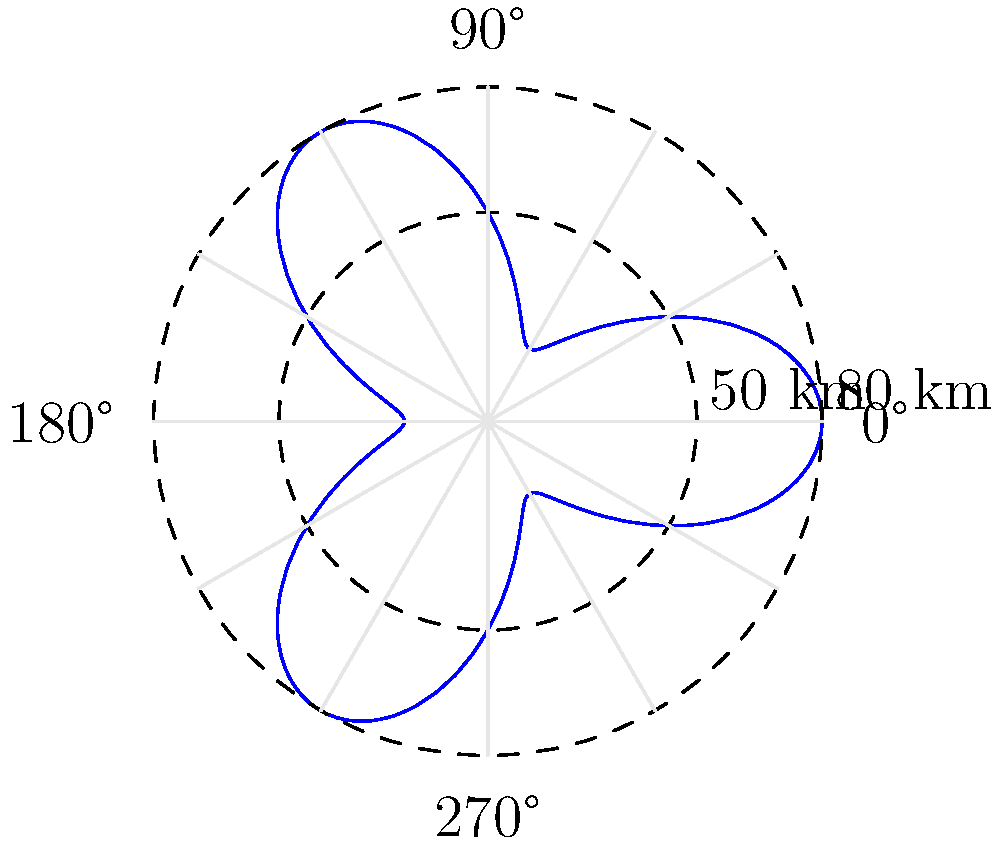A weather radar station has detected a unique pattern of reflectivity data, represented by the blue curve in the polar coordinate system shown above. The radial grid lines are spaced 30° apart, and the concentric circles represent distances of 50 km and 80 km from the radar station. If the equation of this curve in polar coordinates is given by $r = 50 + 30\cos(3\theta)$, where $r$ is in kilometers and $\theta$ is in radians, what is the maximum radial distance of the reflectivity pattern from the radar station? To find the maximum radial distance of the reflectivity pattern, we need to follow these steps:

1) The equation of the curve is given as $r = 50 + 30\cos(3\theta)$.

2) The maximum value of $r$ will occur when $\cos(3\theta)$ is at its maximum, which is 1.

3) Therefore, the maximum value of $r$ is:

   $r_{max} = 50 + 30 \cdot 1 = 80$ km

4) We can verify this by looking at the graph. The blue curve touches the outer dashed circle, which represents 80 km from the radar station.

5) The minimum value would occur when $\cos(3\theta) = -1$, giving:

   $r_{min} = 50 + 30 \cdot (-1) = 20$ km

   This explains why the curve dips inside the 50 km circle in some places.

6) The difference between the maximum and minimum radial distances (80 km - 20 km = 60 km) matches the coefficient of the cosine term in the equation (30 · 2 = 60 km).
Answer: 80 km 